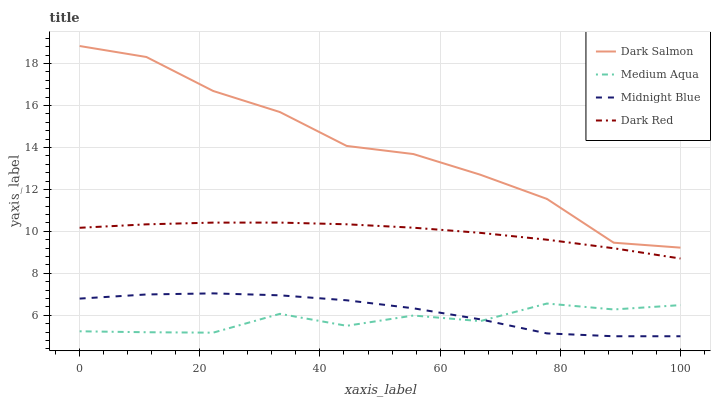Does Medium Aqua have the minimum area under the curve?
Answer yes or no. Yes. Does Dark Salmon have the maximum area under the curve?
Answer yes or no. Yes. Does Dark Salmon have the minimum area under the curve?
Answer yes or no. No. Does Medium Aqua have the maximum area under the curve?
Answer yes or no. No. Is Dark Red the smoothest?
Answer yes or no. Yes. Is Dark Salmon the roughest?
Answer yes or no. Yes. Is Medium Aqua the smoothest?
Answer yes or no. No. Is Medium Aqua the roughest?
Answer yes or no. No. Does Midnight Blue have the lowest value?
Answer yes or no. Yes. Does Medium Aqua have the lowest value?
Answer yes or no. No. Does Dark Salmon have the highest value?
Answer yes or no. Yes. Does Medium Aqua have the highest value?
Answer yes or no. No. Is Dark Red less than Dark Salmon?
Answer yes or no. Yes. Is Dark Salmon greater than Medium Aqua?
Answer yes or no. Yes. Does Midnight Blue intersect Medium Aqua?
Answer yes or no. Yes. Is Midnight Blue less than Medium Aqua?
Answer yes or no. No. Is Midnight Blue greater than Medium Aqua?
Answer yes or no. No. Does Dark Red intersect Dark Salmon?
Answer yes or no. No. 